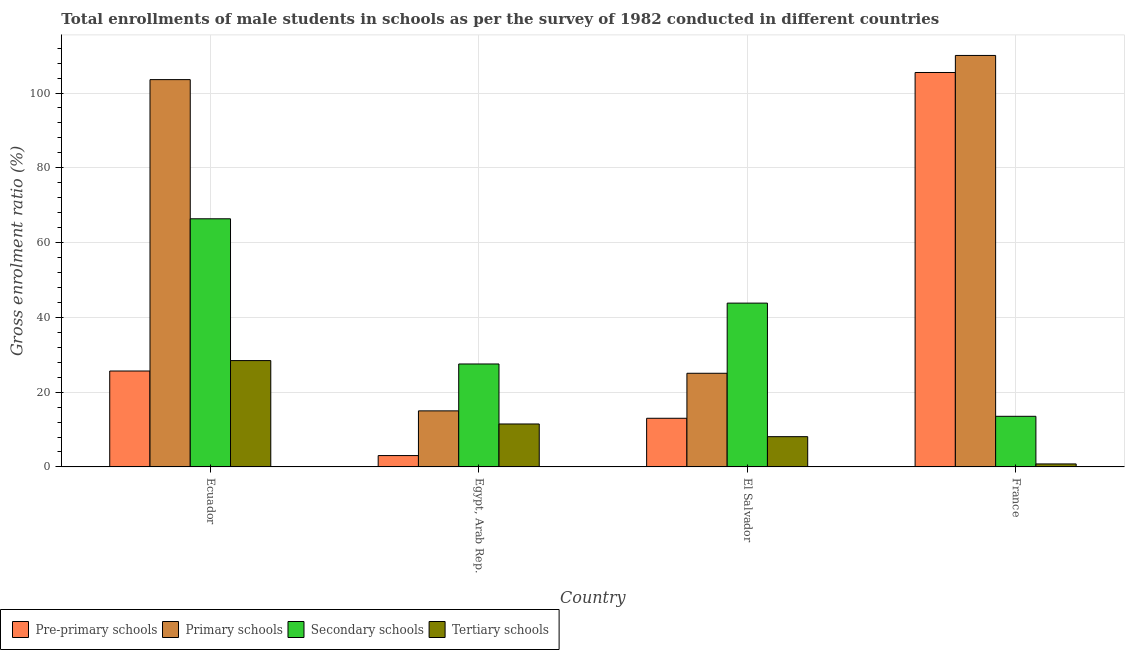How many different coloured bars are there?
Keep it short and to the point. 4. Are the number of bars per tick equal to the number of legend labels?
Keep it short and to the point. Yes. Are the number of bars on each tick of the X-axis equal?
Provide a short and direct response. Yes. How many bars are there on the 4th tick from the left?
Give a very brief answer. 4. What is the label of the 3rd group of bars from the left?
Give a very brief answer. El Salvador. In how many cases, is the number of bars for a given country not equal to the number of legend labels?
Ensure brevity in your answer.  0. What is the gross enrolment ratio(male) in secondary schools in Egypt, Arab Rep.?
Make the answer very short. 27.53. Across all countries, what is the maximum gross enrolment ratio(male) in tertiary schools?
Give a very brief answer. 28.44. Across all countries, what is the minimum gross enrolment ratio(male) in pre-primary schools?
Give a very brief answer. 3.04. In which country was the gross enrolment ratio(male) in pre-primary schools maximum?
Your answer should be compact. France. In which country was the gross enrolment ratio(male) in pre-primary schools minimum?
Provide a succinct answer. Egypt, Arab Rep. What is the total gross enrolment ratio(male) in tertiary schools in the graph?
Your answer should be very brief. 48.82. What is the difference between the gross enrolment ratio(male) in primary schools in Egypt, Arab Rep. and that in France?
Give a very brief answer. -95.05. What is the difference between the gross enrolment ratio(male) in primary schools in Ecuador and the gross enrolment ratio(male) in tertiary schools in Egypt, Arab Rep.?
Provide a succinct answer. 92.1. What is the average gross enrolment ratio(male) in pre-primary schools per country?
Offer a very short reply. 36.8. What is the difference between the gross enrolment ratio(male) in primary schools and gross enrolment ratio(male) in secondary schools in Egypt, Arab Rep.?
Give a very brief answer. -12.54. In how many countries, is the gross enrolment ratio(male) in pre-primary schools greater than 108 %?
Ensure brevity in your answer.  0. What is the ratio of the gross enrolment ratio(male) in tertiary schools in Egypt, Arab Rep. to that in France?
Offer a very short reply. 14.32. What is the difference between the highest and the second highest gross enrolment ratio(male) in primary schools?
Provide a short and direct response. 6.46. What is the difference between the highest and the lowest gross enrolment ratio(male) in primary schools?
Your answer should be very brief. 95.05. In how many countries, is the gross enrolment ratio(male) in tertiary schools greater than the average gross enrolment ratio(male) in tertiary schools taken over all countries?
Your response must be concise. 1. Is the sum of the gross enrolment ratio(male) in primary schools in Ecuador and El Salvador greater than the maximum gross enrolment ratio(male) in pre-primary schools across all countries?
Your answer should be very brief. Yes. What does the 2nd bar from the left in Egypt, Arab Rep. represents?
Provide a short and direct response. Primary schools. What does the 4th bar from the right in El Salvador represents?
Provide a short and direct response. Pre-primary schools. Is it the case that in every country, the sum of the gross enrolment ratio(male) in pre-primary schools and gross enrolment ratio(male) in primary schools is greater than the gross enrolment ratio(male) in secondary schools?
Your response must be concise. No. Are all the bars in the graph horizontal?
Make the answer very short. No. What is the difference between two consecutive major ticks on the Y-axis?
Provide a succinct answer. 20. Are the values on the major ticks of Y-axis written in scientific E-notation?
Give a very brief answer. No. Does the graph contain any zero values?
Provide a short and direct response. No. How many legend labels are there?
Your answer should be compact. 4. How are the legend labels stacked?
Ensure brevity in your answer.  Horizontal. What is the title of the graph?
Your response must be concise. Total enrollments of male students in schools as per the survey of 1982 conducted in different countries. What is the label or title of the X-axis?
Provide a short and direct response. Country. What is the label or title of the Y-axis?
Your answer should be very brief. Gross enrolment ratio (%). What is the Gross enrolment ratio (%) in Pre-primary schools in Ecuador?
Offer a terse response. 25.65. What is the Gross enrolment ratio (%) of Primary schools in Ecuador?
Provide a short and direct response. 103.58. What is the Gross enrolment ratio (%) of Secondary schools in Ecuador?
Your answer should be compact. 66.36. What is the Gross enrolment ratio (%) in Tertiary schools in Ecuador?
Give a very brief answer. 28.44. What is the Gross enrolment ratio (%) in Pre-primary schools in Egypt, Arab Rep.?
Offer a terse response. 3.04. What is the Gross enrolment ratio (%) in Primary schools in Egypt, Arab Rep.?
Your answer should be compact. 14.99. What is the Gross enrolment ratio (%) in Secondary schools in Egypt, Arab Rep.?
Your answer should be very brief. 27.53. What is the Gross enrolment ratio (%) in Tertiary schools in Egypt, Arab Rep.?
Provide a short and direct response. 11.49. What is the Gross enrolment ratio (%) of Pre-primary schools in El Salvador?
Offer a very short reply. 13.01. What is the Gross enrolment ratio (%) in Primary schools in El Salvador?
Provide a succinct answer. 25.05. What is the Gross enrolment ratio (%) in Secondary schools in El Salvador?
Your answer should be compact. 43.81. What is the Gross enrolment ratio (%) in Tertiary schools in El Salvador?
Your answer should be compact. 8.09. What is the Gross enrolment ratio (%) of Pre-primary schools in France?
Your answer should be very brief. 105.49. What is the Gross enrolment ratio (%) in Primary schools in France?
Offer a very short reply. 110.05. What is the Gross enrolment ratio (%) in Secondary schools in France?
Your answer should be very brief. 13.54. What is the Gross enrolment ratio (%) of Tertiary schools in France?
Your response must be concise. 0.8. Across all countries, what is the maximum Gross enrolment ratio (%) of Pre-primary schools?
Provide a succinct answer. 105.49. Across all countries, what is the maximum Gross enrolment ratio (%) in Primary schools?
Ensure brevity in your answer.  110.05. Across all countries, what is the maximum Gross enrolment ratio (%) of Secondary schools?
Your response must be concise. 66.36. Across all countries, what is the maximum Gross enrolment ratio (%) in Tertiary schools?
Offer a terse response. 28.44. Across all countries, what is the minimum Gross enrolment ratio (%) in Pre-primary schools?
Offer a terse response. 3.04. Across all countries, what is the minimum Gross enrolment ratio (%) in Primary schools?
Offer a terse response. 14.99. Across all countries, what is the minimum Gross enrolment ratio (%) of Secondary schools?
Give a very brief answer. 13.54. Across all countries, what is the minimum Gross enrolment ratio (%) of Tertiary schools?
Give a very brief answer. 0.8. What is the total Gross enrolment ratio (%) in Pre-primary schools in the graph?
Provide a short and direct response. 147.19. What is the total Gross enrolment ratio (%) of Primary schools in the graph?
Provide a short and direct response. 253.66. What is the total Gross enrolment ratio (%) of Secondary schools in the graph?
Offer a terse response. 151.24. What is the total Gross enrolment ratio (%) of Tertiary schools in the graph?
Keep it short and to the point. 48.82. What is the difference between the Gross enrolment ratio (%) in Pre-primary schools in Ecuador and that in Egypt, Arab Rep.?
Keep it short and to the point. 22.61. What is the difference between the Gross enrolment ratio (%) in Primary schools in Ecuador and that in Egypt, Arab Rep.?
Provide a short and direct response. 88.59. What is the difference between the Gross enrolment ratio (%) in Secondary schools in Ecuador and that in Egypt, Arab Rep.?
Your answer should be compact. 38.83. What is the difference between the Gross enrolment ratio (%) in Tertiary schools in Ecuador and that in Egypt, Arab Rep.?
Provide a short and direct response. 16.96. What is the difference between the Gross enrolment ratio (%) of Pre-primary schools in Ecuador and that in El Salvador?
Offer a very short reply. 12.64. What is the difference between the Gross enrolment ratio (%) of Primary schools in Ecuador and that in El Salvador?
Your response must be concise. 78.53. What is the difference between the Gross enrolment ratio (%) in Secondary schools in Ecuador and that in El Salvador?
Give a very brief answer. 22.55. What is the difference between the Gross enrolment ratio (%) of Tertiary schools in Ecuador and that in El Salvador?
Your answer should be very brief. 20.35. What is the difference between the Gross enrolment ratio (%) of Pre-primary schools in Ecuador and that in France?
Your response must be concise. -79.83. What is the difference between the Gross enrolment ratio (%) in Primary schools in Ecuador and that in France?
Your answer should be compact. -6.46. What is the difference between the Gross enrolment ratio (%) of Secondary schools in Ecuador and that in France?
Provide a short and direct response. 52.82. What is the difference between the Gross enrolment ratio (%) in Tertiary schools in Ecuador and that in France?
Offer a terse response. 27.64. What is the difference between the Gross enrolment ratio (%) in Pre-primary schools in Egypt, Arab Rep. and that in El Salvador?
Keep it short and to the point. -9.97. What is the difference between the Gross enrolment ratio (%) in Primary schools in Egypt, Arab Rep. and that in El Salvador?
Provide a short and direct response. -10.06. What is the difference between the Gross enrolment ratio (%) in Secondary schools in Egypt, Arab Rep. and that in El Salvador?
Your answer should be very brief. -16.28. What is the difference between the Gross enrolment ratio (%) in Tertiary schools in Egypt, Arab Rep. and that in El Salvador?
Your answer should be very brief. 3.39. What is the difference between the Gross enrolment ratio (%) in Pre-primary schools in Egypt, Arab Rep. and that in France?
Your answer should be compact. -102.45. What is the difference between the Gross enrolment ratio (%) in Primary schools in Egypt, Arab Rep. and that in France?
Offer a very short reply. -95.05. What is the difference between the Gross enrolment ratio (%) of Secondary schools in Egypt, Arab Rep. and that in France?
Ensure brevity in your answer.  14. What is the difference between the Gross enrolment ratio (%) of Tertiary schools in Egypt, Arab Rep. and that in France?
Ensure brevity in your answer.  10.68. What is the difference between the Gross enrolment ratio (%) in Pre-primary schools in El Salvador and that in France?
Your answer should be compact. -92.47. What is the difference between the Gross enrolment ratio (%) of Primary schools in El Salvador and that in France?
Ensure brevity in your answer.  -85. What is the difference between the Gross enrolment ratio (%) of Secondary schools in El Salvador and that in France?
Your answer should be very brief. 30.27. What is the difference between the Gross enrolment ratio (%) in Tertiary schools in El Salvador and that in France?
Provide a short and direct response. 7.29. What is the difference between the Gross enrolment ratio (%) in Pre-primary schools in Ecuador and the Gross enrolment ratio (%) in Primary schools in Egypt, Arab Rep.?
Your response must be concise. 10.66. What is the difference between the Gross enrolment ratio (%) in Pre-primary schools in Ecuador and the Gross enrolment ratio (%) in Secondary schools in Egypt, Arab Rep.?
Give a very brief answer. -1.88. What is the difference between the Gross enrolment ratio (%) of Pre-primary schools in Ecuador and the Gross enrolment ratio (%) of Tertiary schools in Egypt, Arab Rep.?
Offer a terse response. 14.17. What is the difference between the Gross enrolment ratio (%) of Primary schools in Ecuador and the Gross enrolment ratio (%) of Secondary schools in Egypt, Arab Rep.?
Your response must be concise. 76.05. What is the difference between the Gross enrolment ratio (%) of Primary schools in Ecuador and the Gross enrolment ratio (%) of Tertiary schools in Egypt, Arab Rep.?
Ensure brevity in your answer.  92.1. What is the difference between the Gross enrolment ratio (%) in Secondary schools in Ecuador and the Gross enrolment ratio (%) in Tertiary schools in Egypt, Arab Rep.?
Your answer should be very brief. 54.87. What is the difference between the Gross enrolment ratio (%) of Pre-primary schools in Ecuador and the Gross enrolment ratio (%) of Primary schools in El Salvador?
Ensure brevity in your answer.  0.61. What is the difference between the Gross enrolment ratio (%) of Pre-primary schools in Ecuador and the Gross enrolment ratio (%) of Secondary schools in El Salvador?
Your answer should be very brief. -18.16. What is the difference between the Gross enrolment ratio (%) of Pre-primary schools in Ecuador and the Gross enrolment ratio (%) of Tertiary schools in El Salvador?
Your answer should be very brief. 17.56. What is the difference between the Gross enrolment ratio (%) in Primary schools in Ecuador and the Gross enrolment ratio (%) in Secondary schools in El Salvador?
Make the answer very short. 59.77. What is the difference between the Gross enrolment ratio (%) in Primary schools in Ecuador and the Gross enrolment ratio (%) in Tertiary schools in El Salvador?
Give a very brief answer. 95.49. What is the difference between the Gross enrolment ratio (%) in Secondary schools in Ecuador and the Gross enrolment ratio (%) in Tertiary schools in El Salvador?
Offer a very short reply. 58.27. What is the difference between the Gross enrolment ratio (%) of Pre-primary schools in Ecuador and the Gross enrolment ratio (%) of Primary schools in France?
Ensure brevity in your answer.  -84.39. What is the difference between the Gross enrolment ratio (%) of Pre-primary schools in Ecuador and the Gross enrolment ratio (%) of Secondary schools in France?
Your answer should be compact. 12.12. What is the difference between the Gross enrolment ratio (%) in Pre-primary schools in Ecuador and the Gross enrolment ratio (%) in Tertiary schools in France?
Ensure brevity in your answer.  24.85. What is the difference between the Gross enrolment ratio (%) in Primary schools in Ecuador and the Gross enrolment ratio (%) in Secondary schools in France?
Offer a very short reply. 90.04. What is the difference between the Gross enrolment ratio (%) of Primary schools in Ecuador and the Gross enrolment ratio (%) of Tertiary schools in France?
Your answer should be compact. 102.78. What is the difference between the Gross enrolment ratio (%) of Secondary schools in Ecuador and the Gross enrolment ratio (%) of Tertiary schools in France?
Your answer should be very brief. 65.56. What is the difference between the Gross enrolment ratio (%) in Pre-primary schools in Egypt, Arab Rep. and the Gross enrolment ratio (%) in Primary schools in El Salvador?
Your answer should be very brief. -22.01. What is the difference between the Gross enrolment ratio (%) in Pre-primary schools in Egypt, Arab Rep. and the Gross enrolment ratio (%) in Secondary schools in El Salvador?
Keep it short and to the point. -40.77. What is the difference between the Gross enrolment ratio (%) of Pre-primary schools in Egypt, Arab Rep. and the Gross enrolment ratio (%) of Tertiary schools in El Salvador?
Offer a very short reply. -5.05. What is the difference between the Gross enrolment ratio (%) of Primary schools in Egypt, Arab Rep. and the Gross enrolment ratio (%) of Secondary schools in El Salvador?
Provide a short and direct response. -28.82. What is the difference between the Gross enrolment ratio (%) of Primary schools in Egypt, Arab Rep. and the Gross enrolment ratio (%) of Tertiary schools in El Salvador?
Ensure brevity in your answer.  6.9. What is the difference between the Gross enrolment ratio (%) of Secondary schools in Egypt, Arab Rep. and the Gross enrolment ratio (%) of Tertiary schools in El Salvador?
Provide a short and direct response. 19.44. What is the difference between the Gross enrolment ratio (%) of Pre-primary schools in Egypt, Arab Rep. and the Gross enrolment ratio (%) of Primary schools in France?
Your answer should be very brief. -107.01. What is the difference between the Gross enrolment ratio (%) of Pre-primary schools in Egypt, Arab Rep. and the Gross enrolment ratio (%) of Secondary schools in France?
Keep it short and to the point. -10.5. What is the difference between the Gross enrolment ratio (%) in Pre-primary schools in Egypt, Arab Rep. and the Gross enrolment ratio (%) in Tertiary schools in France?
Ensure brevity in your answer.  2.24. What is the difference between the Gross enrolment ratio (%) in Primary schools in Egypt, Arab Rep. and the Gross enrolment ratio (%) in Secondary schools in France?
Your answer should be very brief. 1.45. What is the difference between the Gross enrolment ratio (%) of Primary schools in Egypt, Arab Rep. and the Gross enrolment ratio (%) of Tertiary schools in France?
Offer a terse response. 14.19. What is the difference between the Gross enrolment ratio (%) of Secondary schools in Egypt, Arab Rep. and the Gross enrolment ratio (%) of Tertiary schools in France?
Give a very brief answer. 26.73. What is the difference between the Gross enrolment ratio (%) of Pre-primary schools in El Salvador and the Gross enrolment ratio (%) of Primary schools in France?
Keep it short and to the point. -97.03. What is the difference between the Gross enrolment ratio (%) in Pre-primary schools in El Salvador and the Gross enrolment ratio (%) in Secondary schools in France?
Give a very brief answer. -0.52. What is the difference between the Gross enrolment ratio (%) of Pre-primary schools in El Salvador and the Gross enrolment ratio (%) of Tertiary schools in France?
Provide a short and direct response. 12.21. What is the difference between the Gross enrolment ratio (%) of Primary schools in El Salvador and the Gross enrolment ratio (%) of Secondary schools in France?
Your answer should be compact. 11.51. What is the difference between the Gross enrolment ratio (%) of Primary schools in El Salvador and the Gross enrolment ratio (%) of Tertiary schools in France?
Offer a terse response. 24.24. What is the difference between the Gross enrolment ratio (%) in Secondary schools in El Salvador and the Gross enrolment ratio (%) in Tertiary schools in France?
Your response must be concise. 43.01. What is the average Gross enrolment ratio (%) in Pre-primary schools per country?
Ensure brevity in your answer.  36.8. What is the average Gross enrolment ratio (%) in Primary schools per country?
Your response must be concise. 63.42. What is the average Gross enrolment ratio (%) in Secondary schools per country?
Provide a succinct answer. 37.81. What is the average Gross enrolment ratio (%) in Tertiary schools per country?
Ensure brevity in your answer.  12.21. What is the difference between the Gross enrolment ratio (%) of Pre-primary schools and Gross enrolment ratio (%) of Primary schools in Ecuador?
Keep it short and to the point. -77.93. What is the difference between the Gross enrolment ratio (%) in Pre-primary schools and Gross enrolment ratio (%) in Secondary schools in Ecuador?
Your answer should be very brief. -40.71. What is the difference between the Gross enrolment ratio (%) in Pre-primary schools and Gross enrolment ratio (%) in Tertiary schools in Ecuador?
Your response must be concise. -2.79. What is the difference between the Gross enrolment ratio (%) of Primary schools and Gross enrolment ratio (%) of Secondary schools in Ecuador?
Make the answer very short. 37.22. What is the difference between the Gross enrolment ratio (%) in Primary schools and Gross enrolment ratio (%) in Tertiary schools in Ecuador?
Offer a terse response. 75.14. What is the difference between the Gross enrolment ratio (%) in Secondary schools and Gross enrolment ratio (%) in Tertiary schools in Ecuador?
Your answer should be compact. 37.92. What is the difference between the Gross enrolment ratio (%) of Pre-primary schools and Gross enrolment ratio (%) of Primary schools in Egypt, Arab Rep.?
Provide a succinct answer. -11.95. What is the difference between the Gross enrolment ratio (%) in Pre-primary schools and Gross enrolment ratio (%) in Secondary schools in Egypt, Arab Rep.?
Your response must be concise. -24.49. What is the difference between the Gross enrolment ratio (%) of Pre-primary schools and Gross enrolment ratio (%) of Tertiary schools in Egypt, Arab Rep.?
Offer a very short reply. -8.45. What is the difference between the Gross enrolment ratio (%) of Primary schools and Gross enrolment ratio (%) of Secondary schools in Egypt, Arab Rep.?
Your answer should be very brief. -12.54. What is the difference between the Gross enrolment ratio (%) in Primary schools and Gross enrolment ratio (%) in Tertiary schools in Egypt, Arab Rep.?
Make the answer very short. 3.51. What is the difference between the Gross enrolment ratio (%) of Secondary schools and Gross enrolment ratio (%) of Tertiary schools in Egypt, Arab Rep.?
Your response must be concise. 16.05. What is the difference between the Gross enrolment ratio (%) of Pre-primary schools and Gross enrolment ratio (%) of Primary schools in El Salvador?
Make the answer very short. -12.03. What is the difference between the Gross enrolment ratio (%) in Pre-primary schools and Gross enrolment ratio (%) in Secondary schools in El Salvador?
Ensure brevity in your answer.  -30.8. What is the difference between the Gross enrolment ratio (%) of Pre-primary schools and Gross enrolment ratio (%) of Tertiary schools in El Salvador?
Offer a very short reply. 4.92. What is the difference between the Gross enrolment ratio (%) in Primary schools and Gross enrolment ratio (%) in Secondary schools in El Salvador?
Offer a terse response. -18.76. What is the difference between the Gross enrolment ratio (%) of Primary schools and Gross enrolment ratio (%) of Tertiary schools in El Salvador?
Give a very brief answer. 16.95. What is the difference between the Gross enrolment ratio (%) of Secondary schools and Gross enrolment ratio (%) of Tertiary schools in El Salvador?
Offer a very short reply. 35.72. What is the difference between the Gross enrolment ratio (%) in Pre-primary schools and Gross enrolment ratio (%) in Primary schools in France?
Offer a terse response. -4.56. What is the difference between the Gross enrolment ratio (%) of Pre-primary schools and Gross enrolment ratio (%) of Secondary schools in France?
Your answer should be compact. 91.95. What is the difference between the Gross enrolment ratio (%) of Pre-primary schools and Gross enrolment ratio (%) of Tertiary schools in France?
Ensure brevity in your answer.  104.69. What is the difference between the Gross enrolment ratio (%) of Primary schools and Gross enrolment ratio (%) of Secondary schools in France?
Offer a terse response. 96.51. What is the difference between the Gross enrolment ratio (%) of Primary schools and Gross enrolment ratio (%) of Tertiary schools in France?
Ensure brevity in your answer.  109.24. What is the difference between the Gross enrolment ratio (%) in Secondary schools and Gross enrolment ratio (%) in Tertiary schools in France?
Provide a short and direct response. 12.74. What is the ratio of the Gross enrolment ratio (%) in Pre-primary schools in Ecuador to that in Egypt, Arab Rep.?
Your answer should be compact. 8.44. What is the ratio of the Gross enrolment ratio (%) of Primary schools in Ecuador to that in Egypt, Arab Rep.?
Your answer should be compact. 6.91. What is the ratio of the Gross enrolment ratio (%) in Secondary schools in Ecuador to that in Egypt, Arab Rep.?
Make the answer very short. 2.41. What is the ratio of the Gross enrolment ratio (%) of Tertiary schools in Ecuador to that in Egypt, Arab Rep.?
Your response must be concise. 2.48. What is the ratio of the Gross enrolment ratio (%) of Pre-primary schools in Ecuador to that in El Salvador?
Provide a short and direct response. 1.97. What is the ratio of the Gross enrolment ratio (%) of Primary schools in Ecuador to that in El Salvador?
Give a very brief answer. 4.14. What is the ratio of the Gross enrolment ratio (%) of Secondary schools in Ecuador to that in El Salvador?
Ensure brevity in your answer.  1.51. What is the ratio of the Gross enrolment ratio (%) of Tertiary schools in Ecuador to that in El Salvador?
Your answer should be very brief. 3.51. What is the ratio of the Gross enrolment ratio (%) in Pre-primary schools in Ecuador to that in France?
Your answer should be very brief. 0.24. What is the ratio of the Gross enrolment ratio (%) in Primary schools in Ecuador to that in France?
Provide a short and direct response. 0.94. What is the ratio of the Gross enrolment ratio (%) in Secondary schools in Ecuador to that in France?
Your response must be concise. 4.9. What is the ratio of the Gross enrolment ratio (%) of Tertiary schools in Ecuador to that in France?
Offer a terse response. 35.47. What is the ratio of the Gross enrolment ratio (%) in Pre-primary schools in Egypt, Arab Rep. to that in El Salvador?
Your answer should be very brief. 0.23. What is the ratio of the Gross enrolment ratio (%) in Primary schools in Egypt, Arab Rep. to that in El Salvador?
Provide a short and direct response. 0.6. What is the ratio of the Gross enrolment ratio (%) in Secondary schools in Egypt, Arab Rep. to that in El Salvador?
Your response must be concise. 0.63. What is the ratio of the Gross enrolment ratio (%) of Tertiary schools in Egypt, Arab Rep. to that in El Salvador?
Your response must be concise. 1.42. What is the ratio of the Gross enrolment ratio (%) in Pre-primary schools in Egypt, Arab Rep. to that in France?
Offer a very short reply. 0.03. What is the ratio of the Gross enrolment ratio (%) of Primary schools in Egypt, Arab Rep. to that in France?
Make the answer very short. 0.14. What is the ratio of the Gross enrolment ratio (%) in Secondary schools in Egypt, Arab Rep. to that in France?
Your answer should be compact. 2.03. What is the ratio of the Gross enrolment ratio (%) of Tertiary schools in Egypt, Arab Rep. to that in France?
Make the answer very short. 14.32. What is the ratio of the Gross enrolment ratio (%) in Pre-primary schools in El Salvador to that in France?
Offer a very short reply. 0.12. What is the ratio of the Gross enrolment ratio (%) of Primary schools in El Salvador to that in France?
Make the answer very short. 0.23. What is the ratio of the Gross enrolment ratio (%) of Secondary schools in El Salvador to that in France?
Give a very brief answer. 3.24. What is the ratio of the Gross enrolment ratio (%) of Tertiary schools in El Salvador to that in France?
Make the answer very short. 10.09. What is the difference between the highest and the second highest Gross enrolment ratio (%) in Pre-primary schools?
Your answer should be compact. 79.83. What is the difference between the highest and the second highest Gross enrolment ratio (%) of Primary schools?
Offer a terse response. 6.46. What is the difference between the highest and the second highest Gross enrolment ratio (%) of Secondary schools?
Ensure brevity in your answer.  22.55. What is the difference between the highest and the second highest Gross enrolment ratio (%) of Tertiary schools?
Provide a succinct answer. 16.96. What is the difference between the highest and the lowest Gross enrolment ratio (%) of Pre-primary schools?
Provide a succinct answer. 102.45. What is the difference between the highest and the lowest Gross enrolment ratio (%) in Primary schools?
Offer a very short reply. 95.05. What is the difference between the highest and the lowest Gross enrolment ratio (%) of Secondary schools?
Offer a very short reply. 52.82. What is the difference between the highest and the lowest Gross enrolment ratio (%) in Tertiary schools?
Keep it short and to the point. 27.64. 